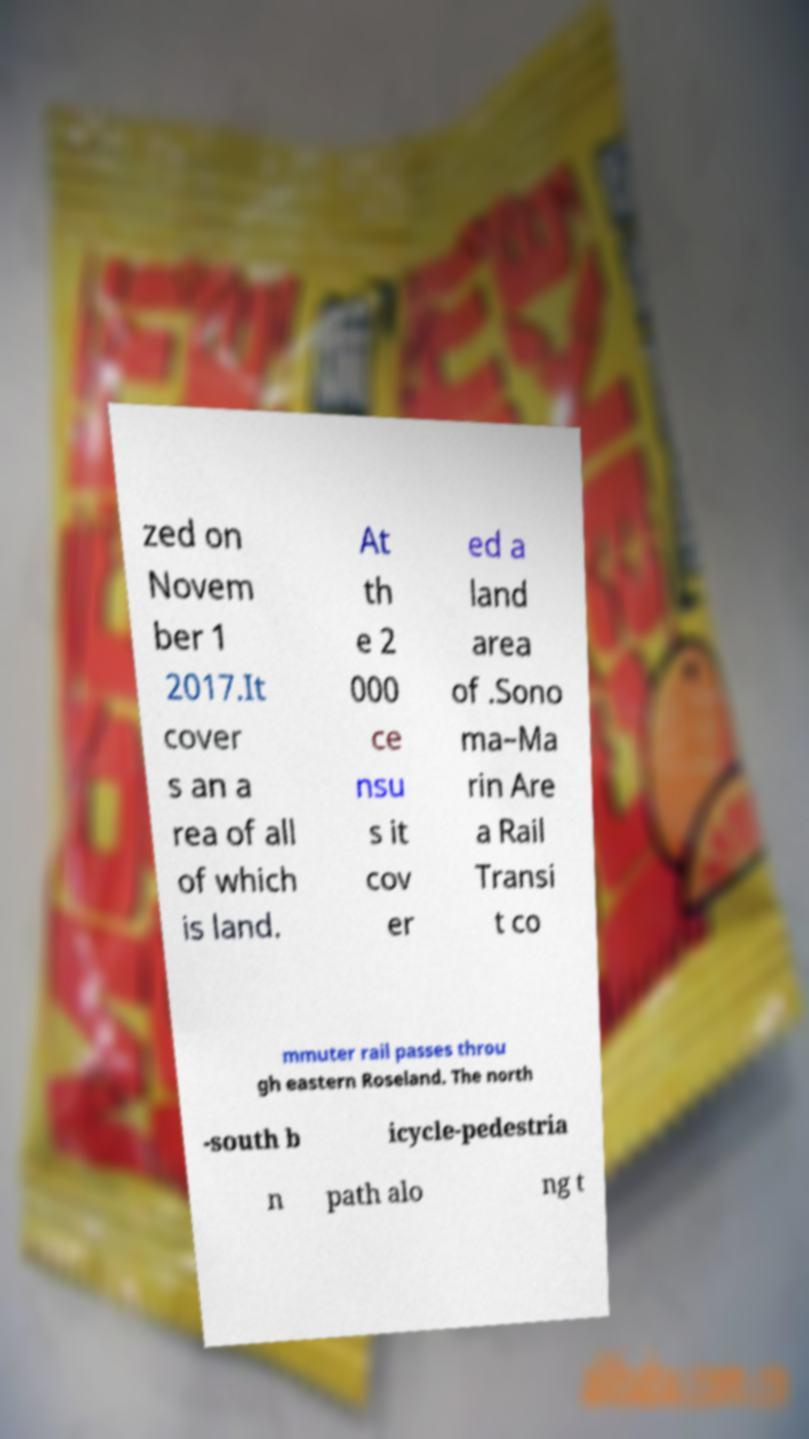Can you accurately transcribe the text from the provided image for me? zed on Novem ber 1 2017.It cover s an a rea of all of which is land. At th e 2 000 ce nsu s it cov er ed a land area of .Sono ma–Ma rin Are a Rail Transi t co mmuter rail passes throu gh eastern Roseland. The north -south b icycle-pedestria n path alo ng t 